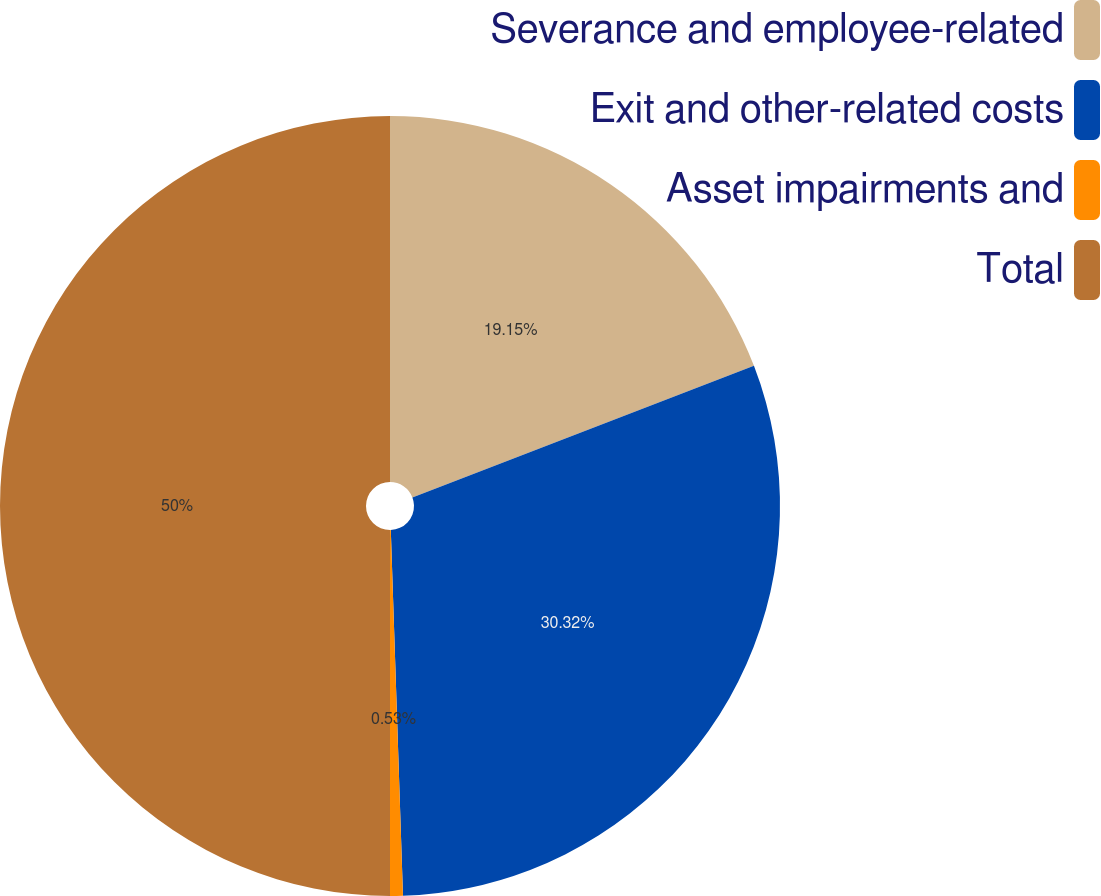Convert chart to OTSL. <chart><loc_0><loc_0><loc_500><loc_500><pie_chart><fcel>Severance and employee-related<fcel>Exit and other-related costs<fcel>Asset impairments and<fcel>Total<nl><fcel>19.15%<fcel>30.32%<fcel>0.53%<fcel>50.0%<nl></chart> 